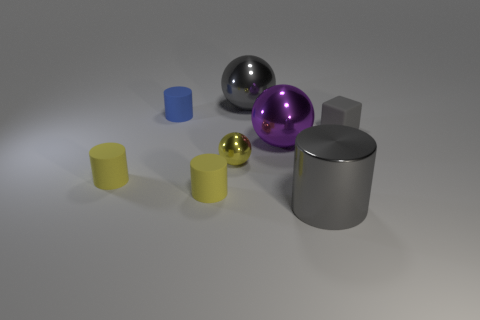Add 1 large green rubber spheres. How many objects exist? 9 Subtract all large metallic balls. How many balls are left? 1 Subtract 2 cylinders. How many cylinders are left? 2 Subtract all brown spheres. How many yellow cylinders are left? 2 Subtract all purple balls. How many balls are left? 2 Subtract all spheres. How many objects are left? 5 Subtract all metal objects. Subtract all big purple metal things. How many objects are left? 3 Add 3 small yellow matte cylinders. How many small yellow matte cylinders are left? 5 Add 3 small gray matte blocks. How many small gray matte blocks exist? 4 Subtract 0 green cubes. How many objects are left? 8 